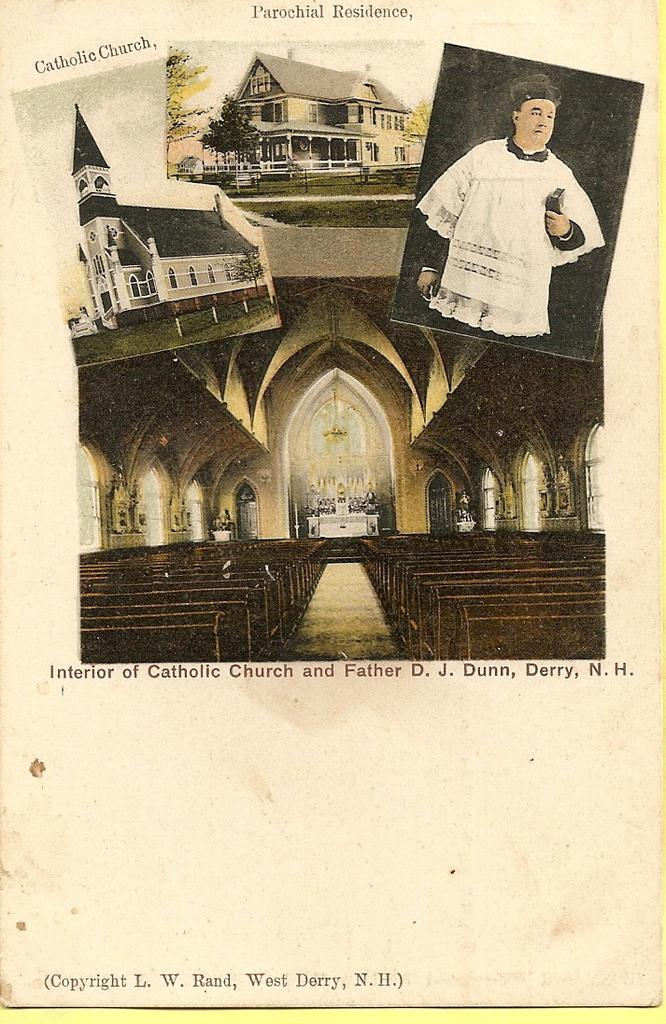What is the main subject of the paper in the image? The paper contains photos of buildings and a person. What type of images can be seen on the paper? The paper contains photos of buildings and a person. Is there any text on the paper? Yes, there is text on the paper. Can you describe the road that is visible in the image? There is no road visible in the image; the image contains a paper with photos and text. What type of sponge is being used by the person in the image? There is no sponge present in the image; it contains photos of a person and text. 